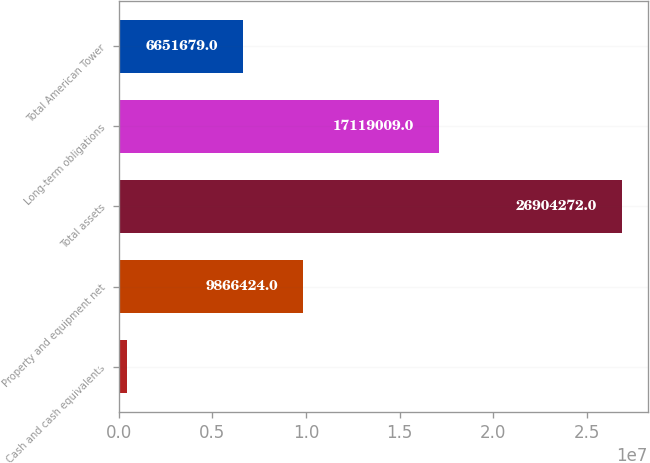Convert chart to OTSL. <chart><loc_0><loc_0><loc_500><loc_500><bar_chart><fcel>Cash and cash equivalents<fcel>Property and equipment net<fcel>Total assets<fcel>Long-term obligations<fcel>Total American Tower<nl><fcel>462879<fcel>9.86642e+06<fcel>2.69043e+07<fcel>1.7119e+07<fcel>6.65168e+06<nl></chart> 